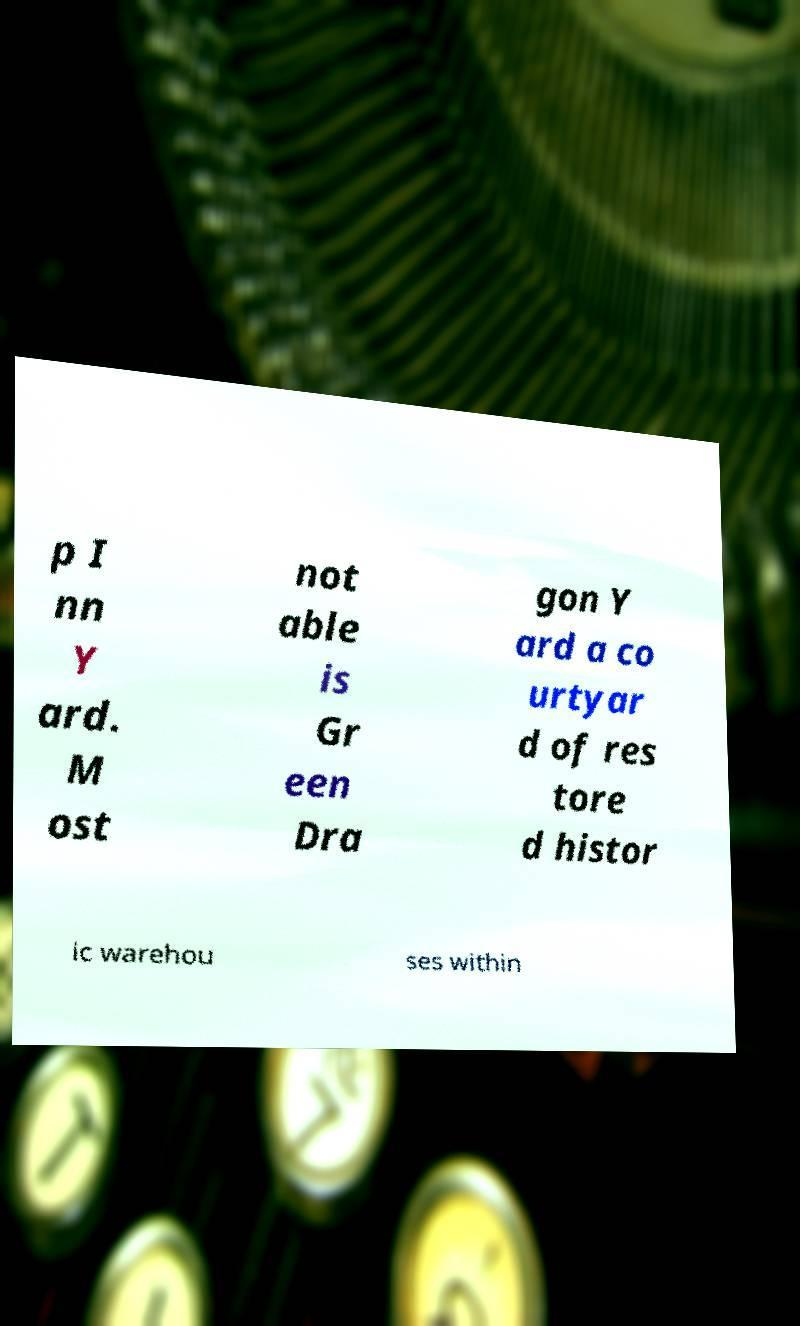There's text embedded in this image that I need extracted. Can you transcribe it verbatim? p I nn Y ard. M ost not able is Gr een Dra gon Y ard a co urtyar d of res tore d histor ic warehou ses within 